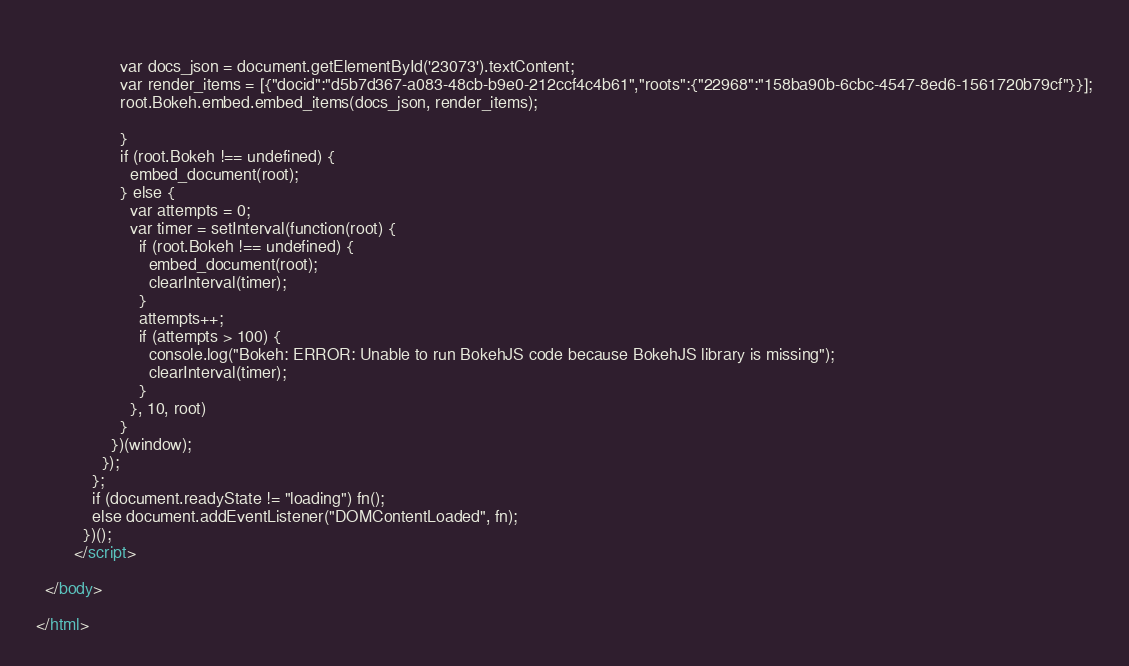<code> <loc_0><loc_0><loc_500><loc_500><_HTML_>                    
                  var docs_json = document.getElementById('23073').textContent;
                  var render_items = [{"docid":"d5b7d367-a083-48cb-b9e0-212ccf4c4b61","roots":{"22968":"158ba90b-6cbc-4547-8ed6-1561720b79cf"}}];
                  root.Bokeh.embed.embed_items(docs_json, render_items);
                
                  }
                  if (root.Bokeh !== undefined) {
                    embed_document(root);
                  } else {
                    var attempts = 0;
                    var timer = setInterval(function(root) {
                      if (root.Bokeh !== undefined) {
                        embed_document(root);
                        clearInterval(timer);
                      }
                      attempts++;
                      if (attempts > 100) {
                        console.log("Bokeh: ERROR: Unable to run BokehJS code because BokehJS library is missing");
                        clearInterval(timer);
                      }
                    }, 10, root)
                  }
                })(window);
              });
            };
            if (document.readyState != "loading") fn();
            else document.addEventListener("DOMContentLoaded", fn);
          })();
        </script>
    
  </body>
  
</html></code> 